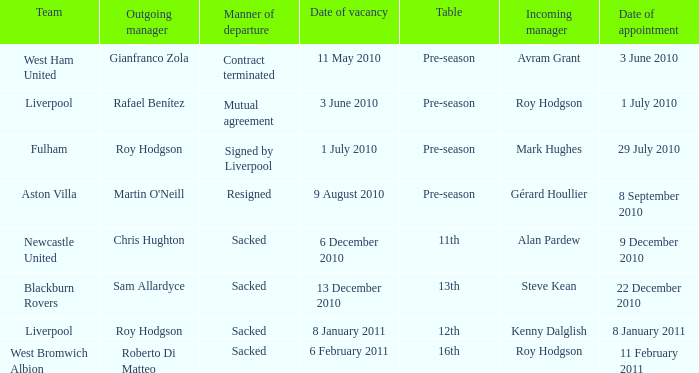What squad is obtaining a manager known as kenny dalglish? Liverpool. 